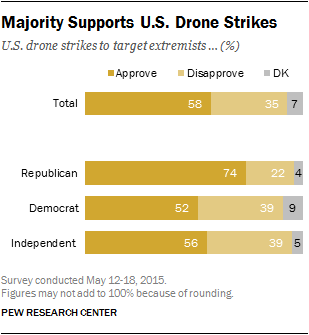Highlight a few significant elements in this photo. The approval rate for the total population is 58%. A total of two political parties have approval rates above 55% in their stance towards drone strikes. 